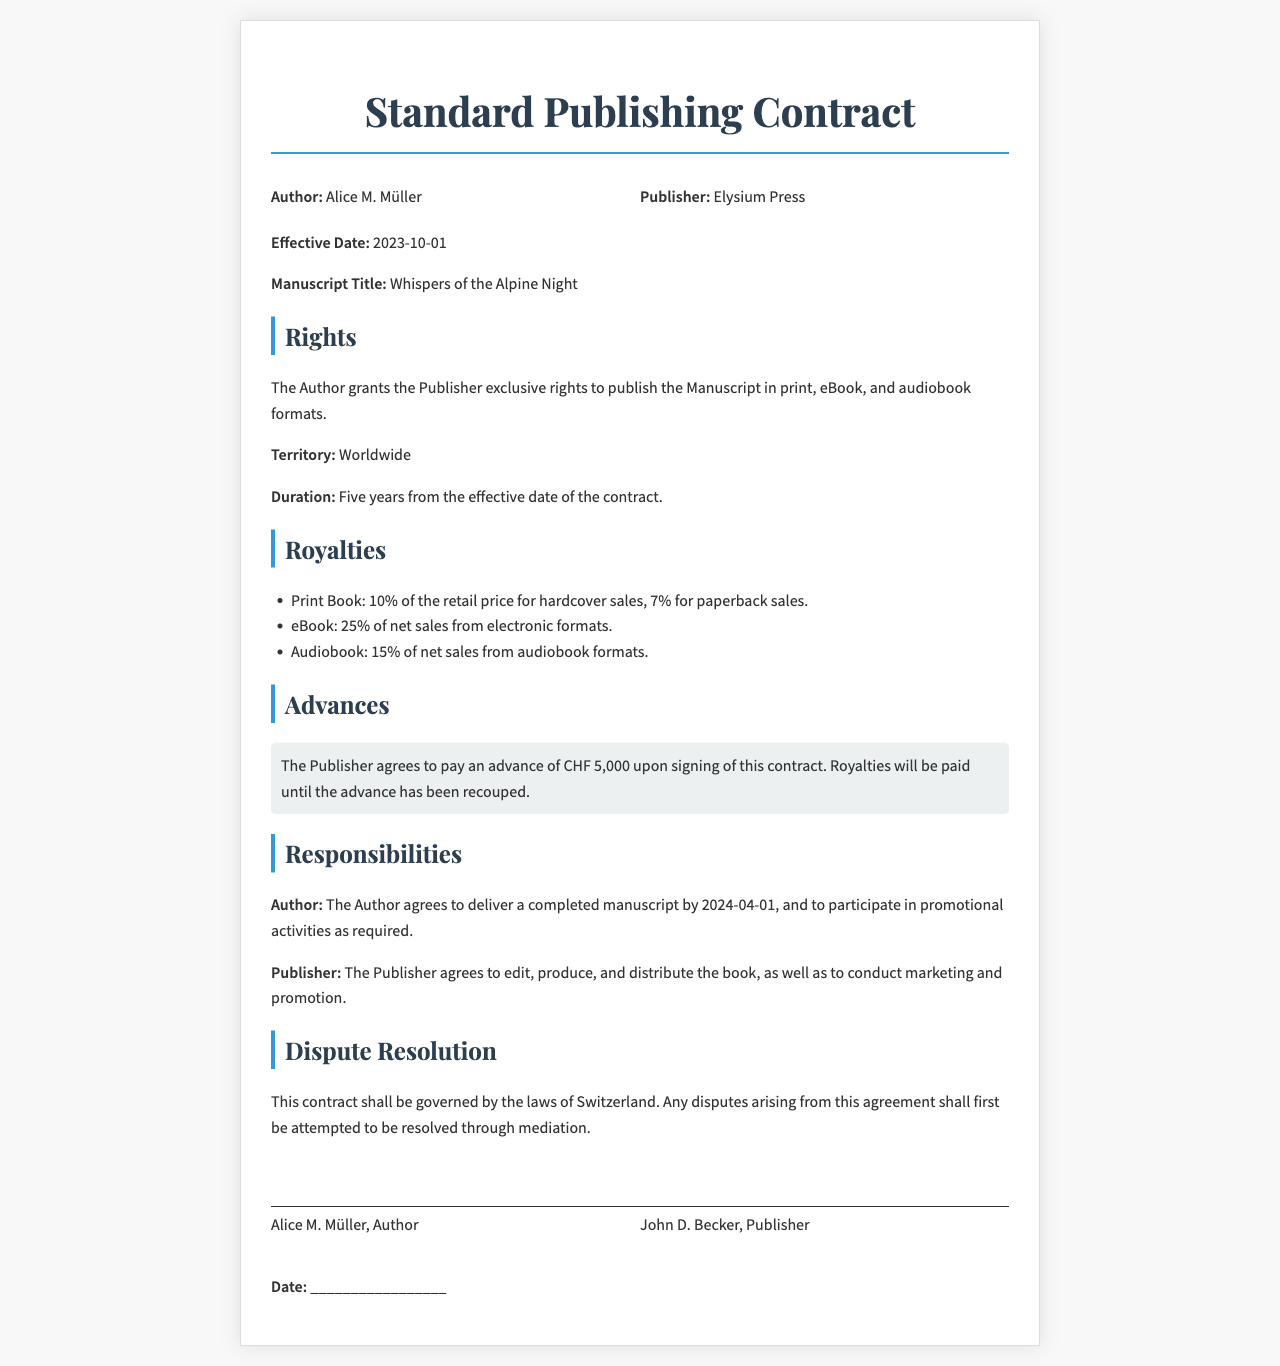What is the effective date of the contract? The effective date is clearly stated in the contract, which is 2023-10-01.
Answer: 2023-10-01 What is the name of the manuscript? The manuscript title is provided in the document, which is "Whispers of the Alpine Night."
Answer: Whispers of the Alpine Night How long is the duration of the rights granted to the publisher? The contract specifies that the duration is five years from the effective date.
Answer: Five years What is the advance payment amount? The document states that the publisher agrees to pay an advance of CHF 5,000 upon signing.
Answer: CHF 5,000 What percentage of net sales does the author receive for eBook formats? The contract outlines the royalty structure, indicating that the author receives 25% for eBook sales.
Answer: 25% What responsibilities does the publisher have according to the contract? The contract mentions that the publisher agrees to edit, produce, and distribute the book, including marketing.
Answer: Edit, produce, and distribute the book How will disputes be resolved according to the contract? The document specifies that disputes will first be attempted to be resolved through mediation.
Answer: Mediation Who is the author of the manuscript? The author's name is provided at the beginning of the document as Alice M. Müller.
Answer: Alice M. Müller What percentage of retail price does the author receive for paperback sales? The contract states that the author receives 7% of the retail price for paperback sales.
Answer: 7% 